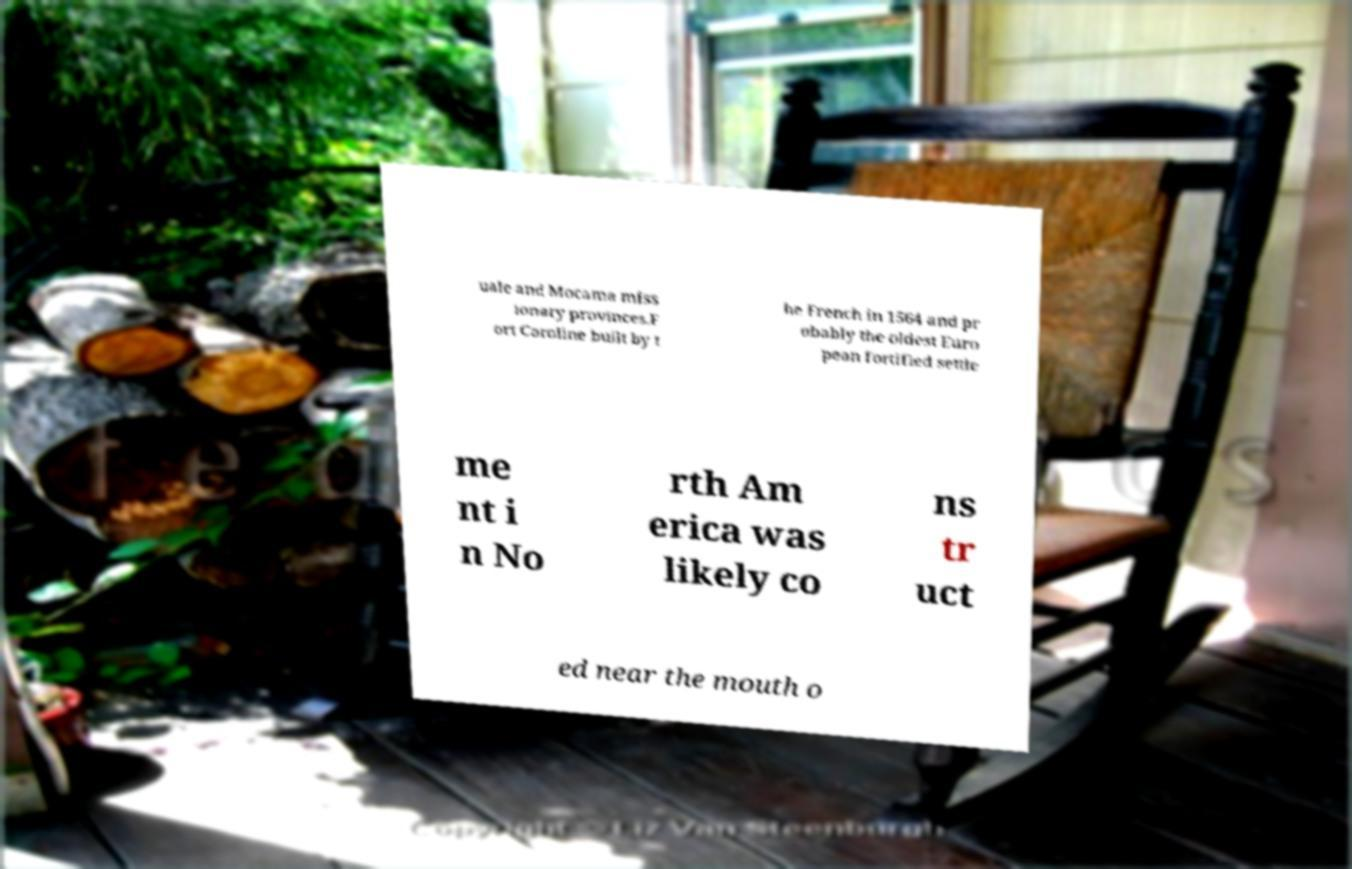Please read and relay the text visible in this image. What does it say? uale and Mocama miss ionary provinces.F ort Caroline built by t he French in 1564 and pr obably the oldest Euro pean fortified settle me nt i n No rth Am erica was likely co ns tr uct ed near the mouth o 